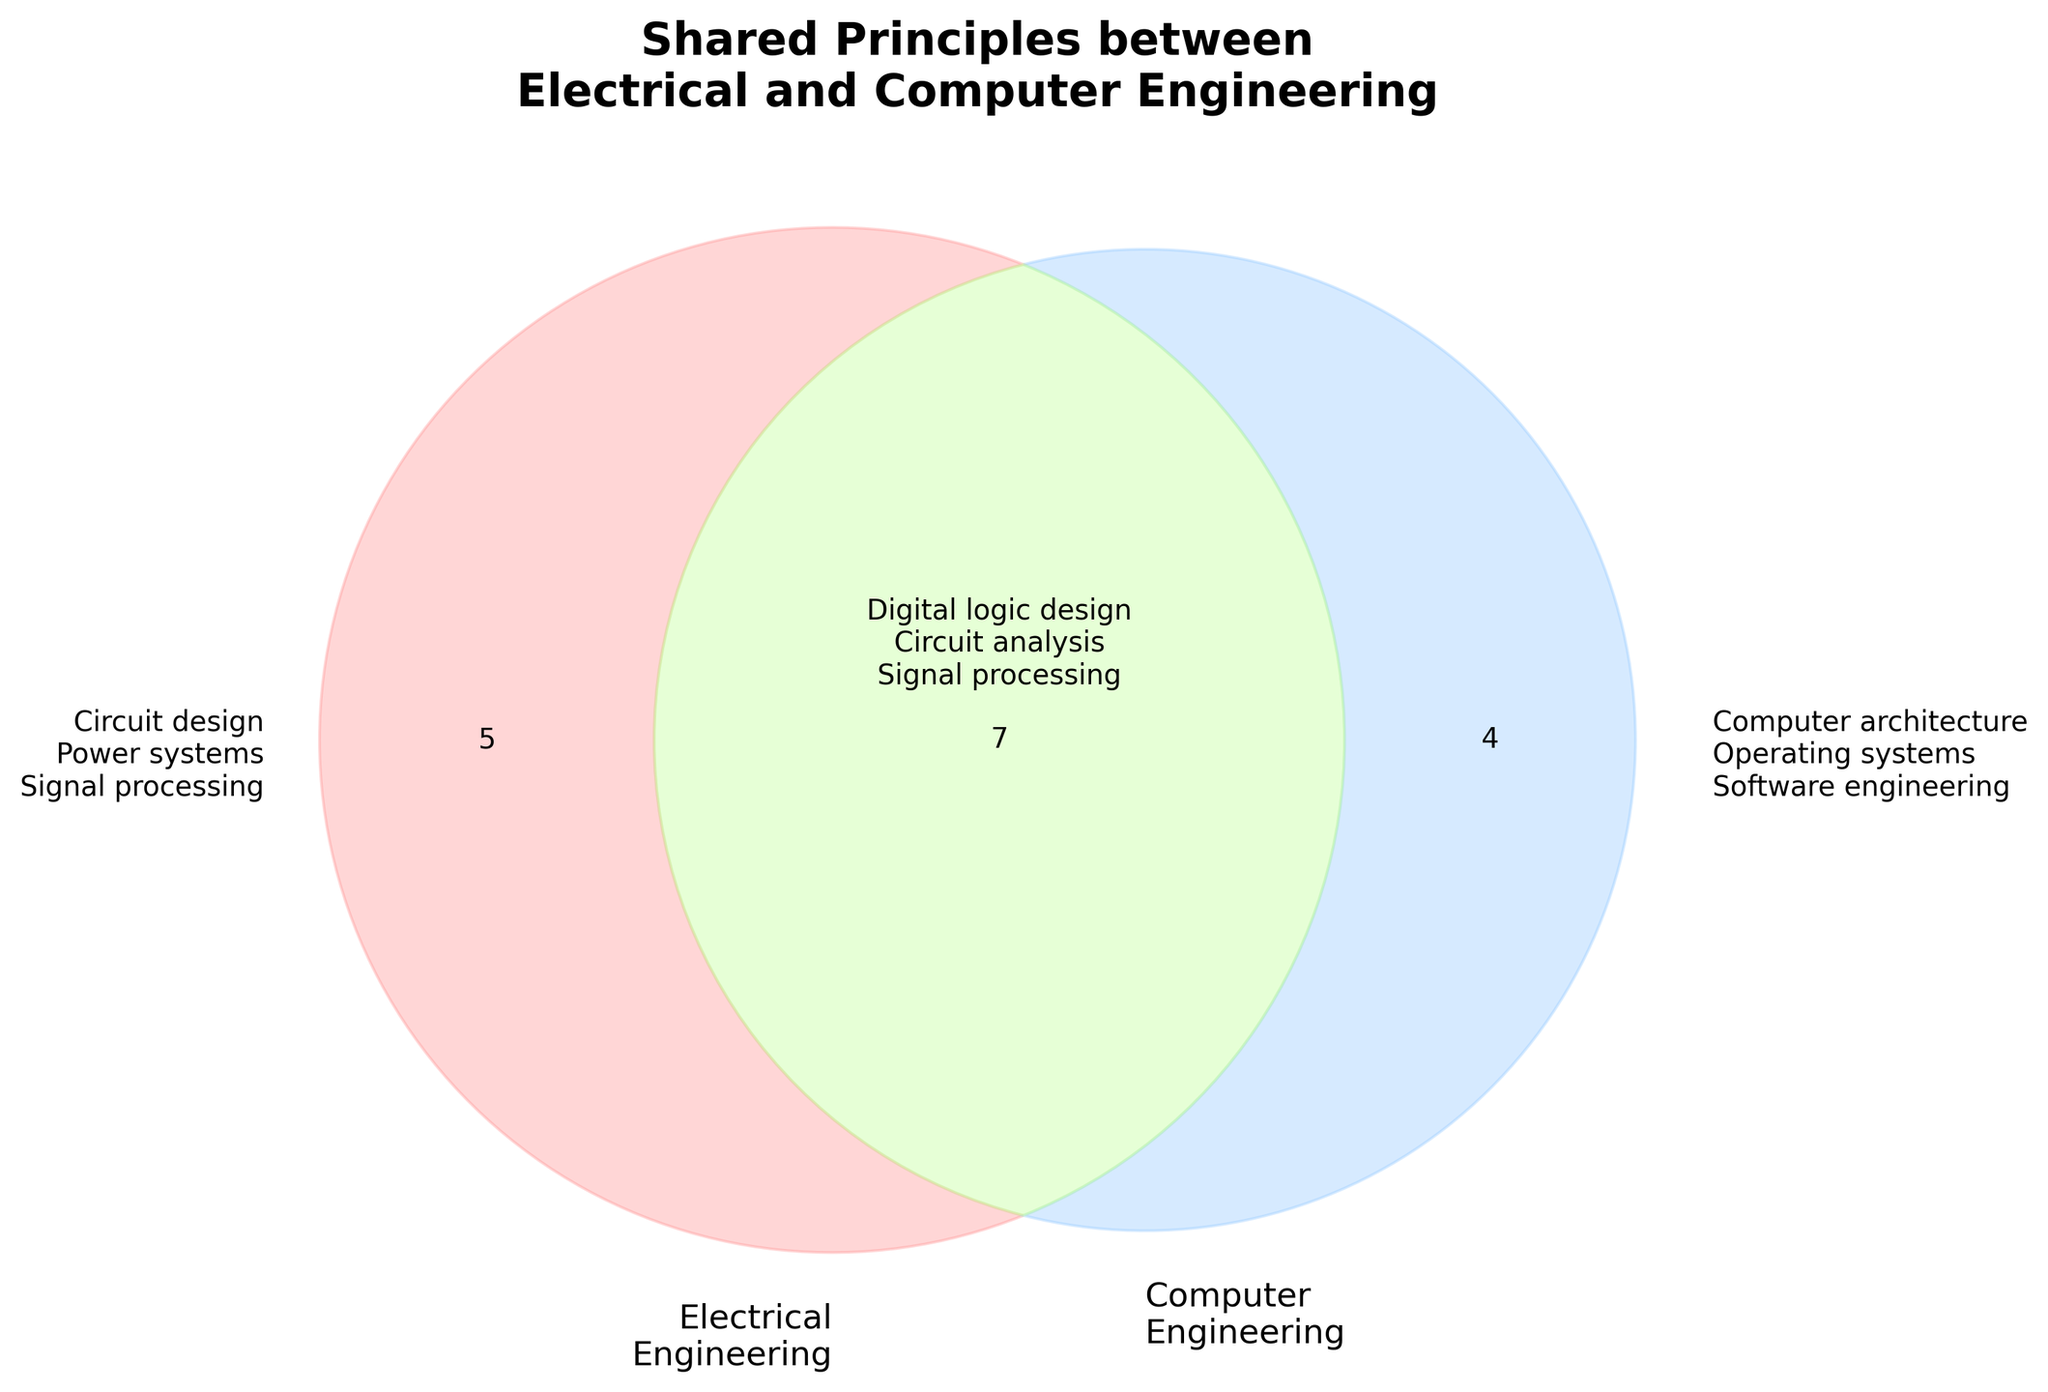What is the title of the Venn diagram? The title is located at the top of the figure, indicating the main topic of the visualization.
Answer: Shared Principles between Electrical and Computer Engineering Which field has 'Circuit design' as a principle? Look at the left circle labeled 'Electrical Engineering', 'Circuit design' is listed under this section.
Answer: Electrical Engineering Name two principles that are shared between Electrical and Computer Engineering. Focus on the overlapping area of the Venn diagram; it contains the shared principles like 'Digital logic design' and 'Circuit analysis'.
Answer: Digital logic design, Circuit analysis Which engineering discipline has more unique principles listed? Compare the number of principles in the left circle for Electrical Engineering and the right circle for Computer Engineering; Electrical Engineering has more.
Answer: Electrical Engineering How many principles are shared between the two disciplines? Count the principles in the overlapping section of the Venn diagram. There are seven in total.
Answer: Seven Identify a principle that applies to both fields but also to the embedded systems. Look for shared and embedded principles in the overlapping area, such as 'Digital logic design'.
Answer: Digital logic design 